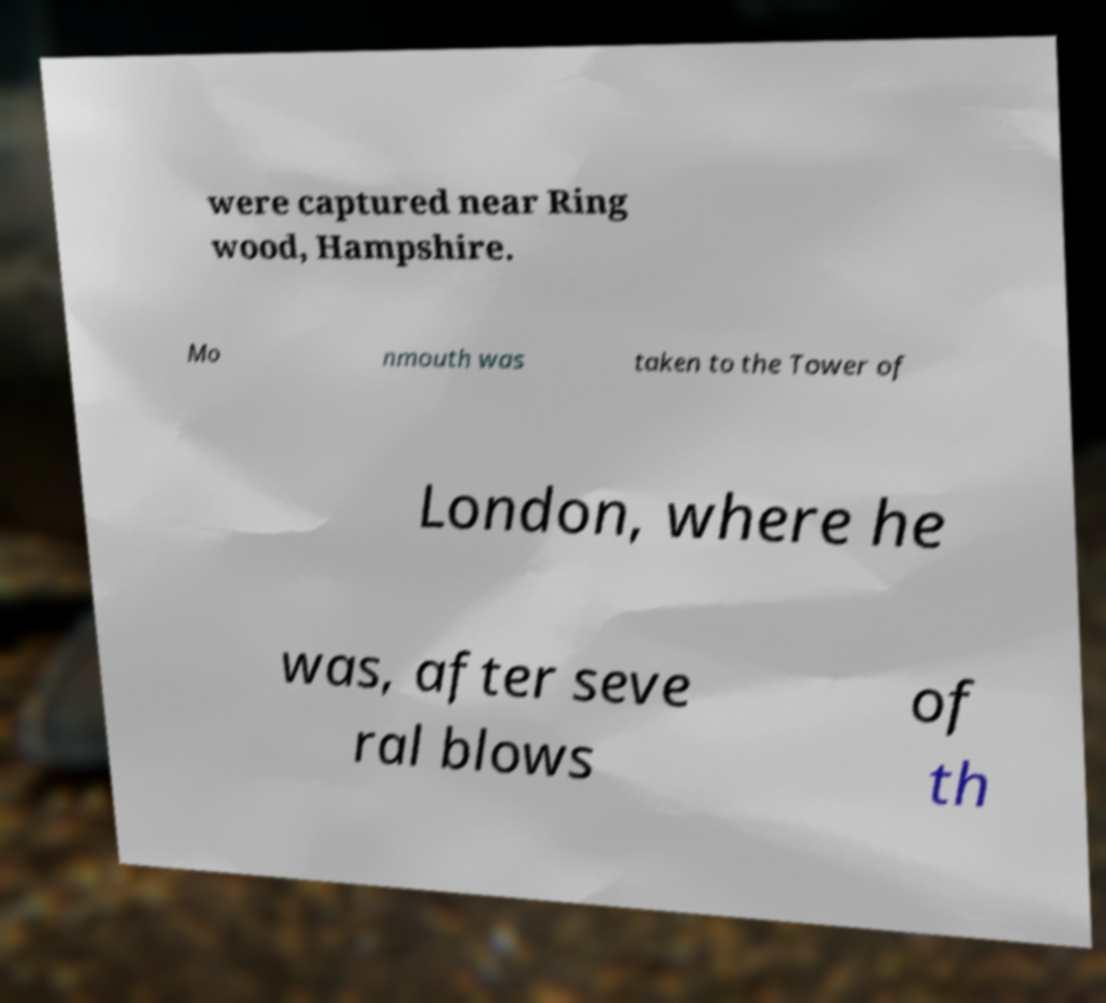I need the written content from this picture converted into text. Can you do that? were captured near Ring wood, Hampshire. Mo nmouth was taken to the Tower of London, where he was, after seve ral blows of th 